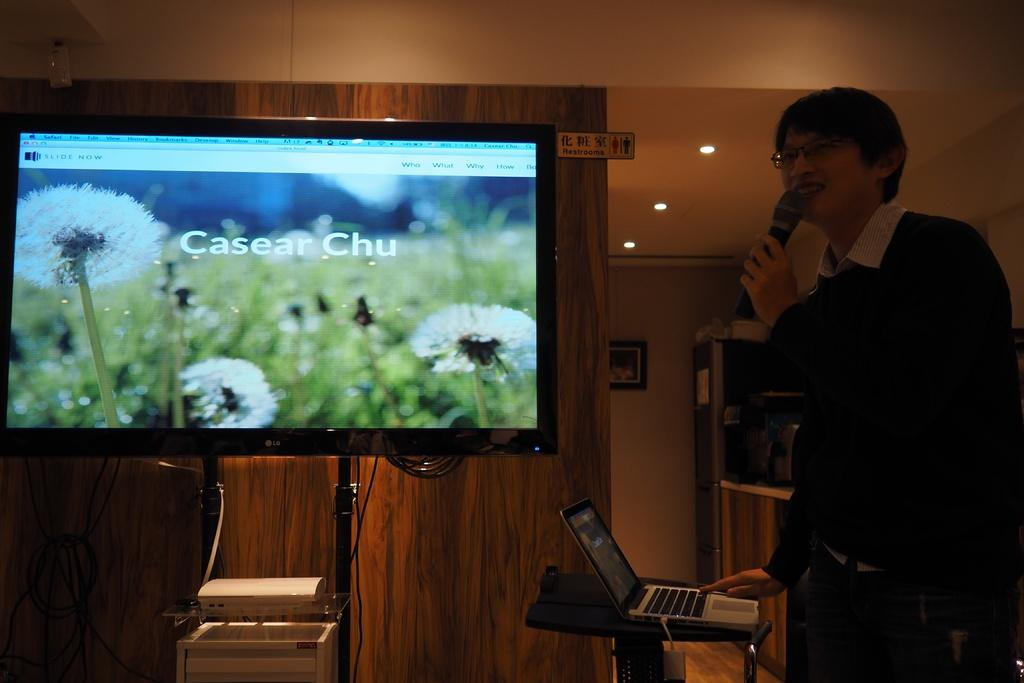Provide a one-sentence caption for the provided image. A man with a microphone showing a slide that says Casear Chu. 